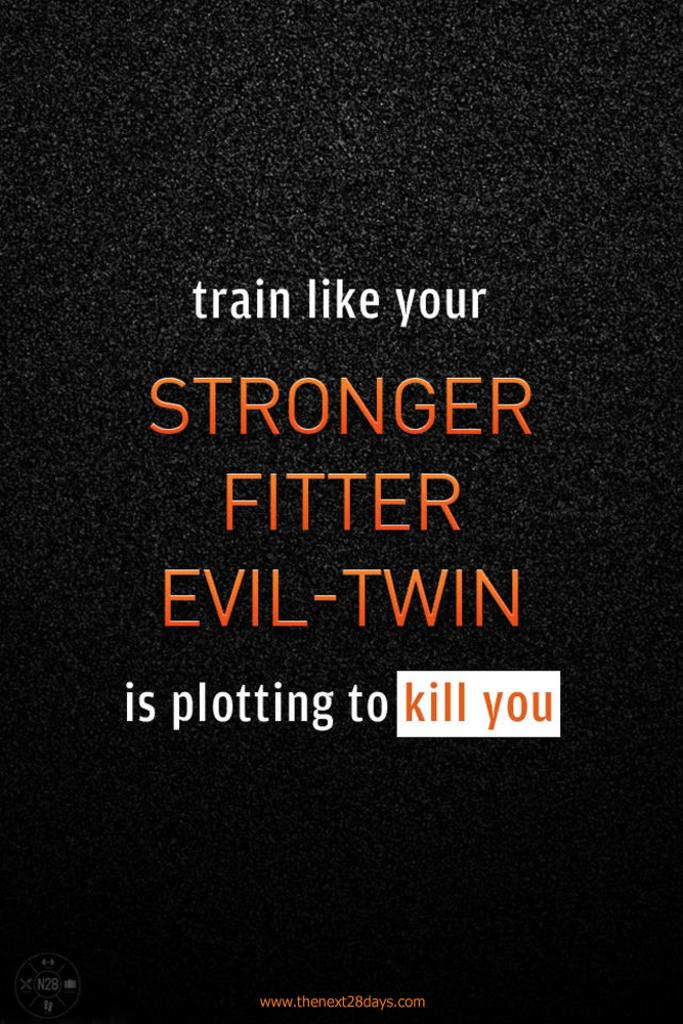Provide a one-sentence caption for the provided image. Sign that says "Train like your evil twin is trying to kill you". 